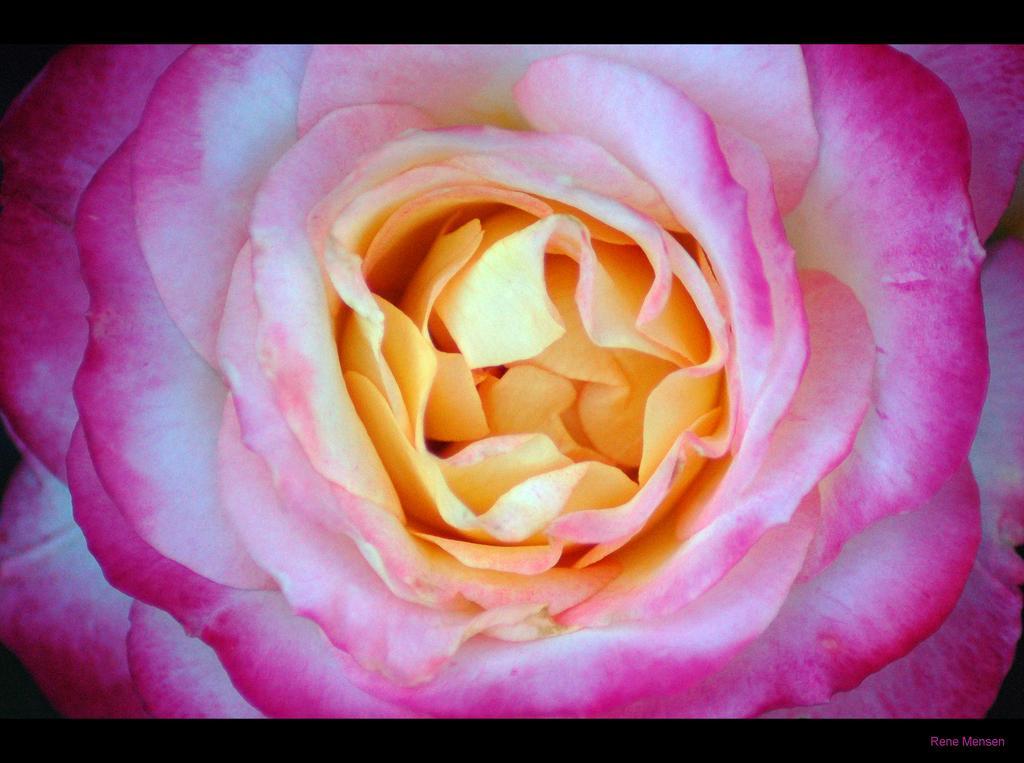Describe this image in one or two sentences. In this image, we can see a rose flower. At the top and bottom of the image, we can see black color. On the right side bottom corner, there is a watermark in the image. 